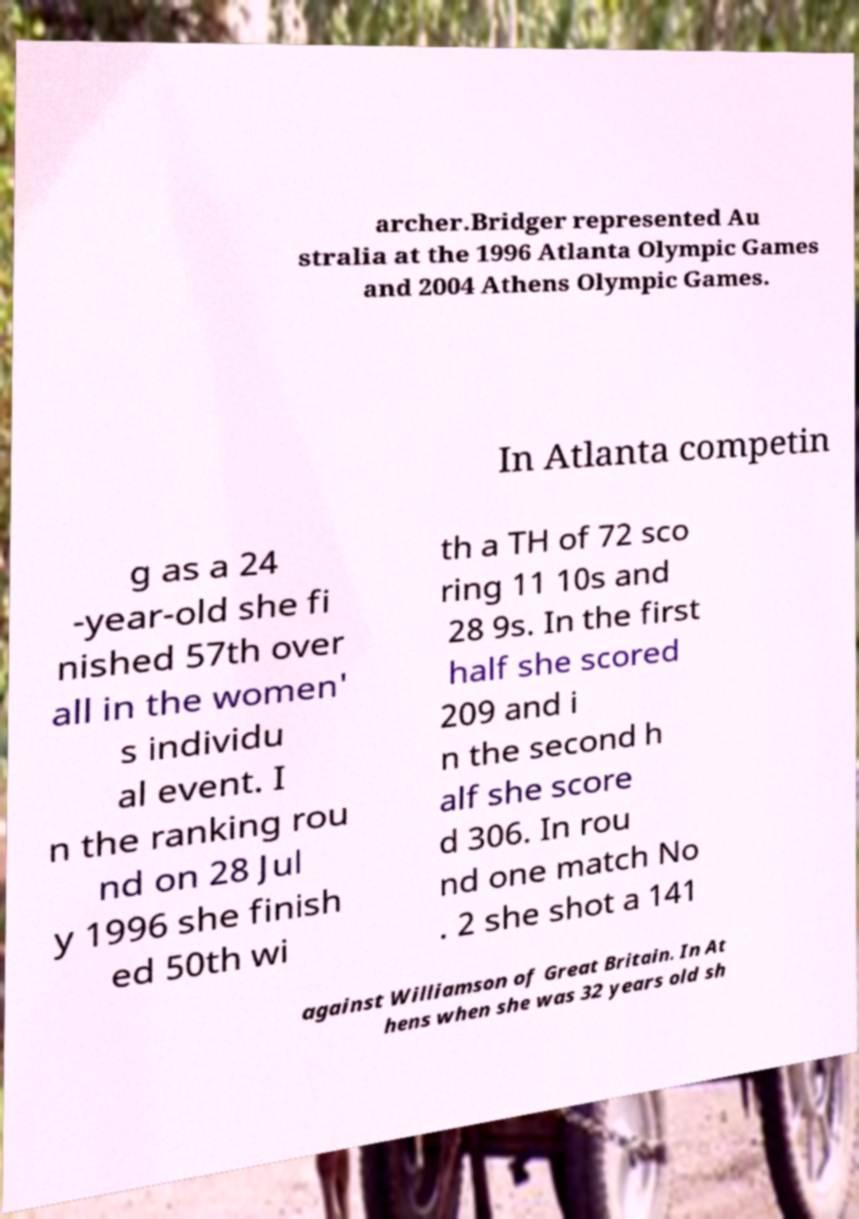Please read and relay the text visible in this image. What does it say? archer.Bridger represented Au stralia at the 1996 Atlanta Olympic Games and 2004 Athens Olympic Games. In Atlanta competin g as a 24 -year-old she fi nished 57th over all in the women' s individu al event. I n the ranking rou nd on 28 Jul y 1996 she finish ed 50th wi th a TH of 72 sco ring 11 10s and 28 9s. In the first half she scored 209 and i n the second h alf she score d 306. In rou nd one match No . 2 she shot a 141 against Williamson of Great Britain. In At hens when she was 32 years old sh 